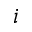Convert formula to latex. <formula><loc_0><loc_0><loc_500><loc_500>i</formula> 